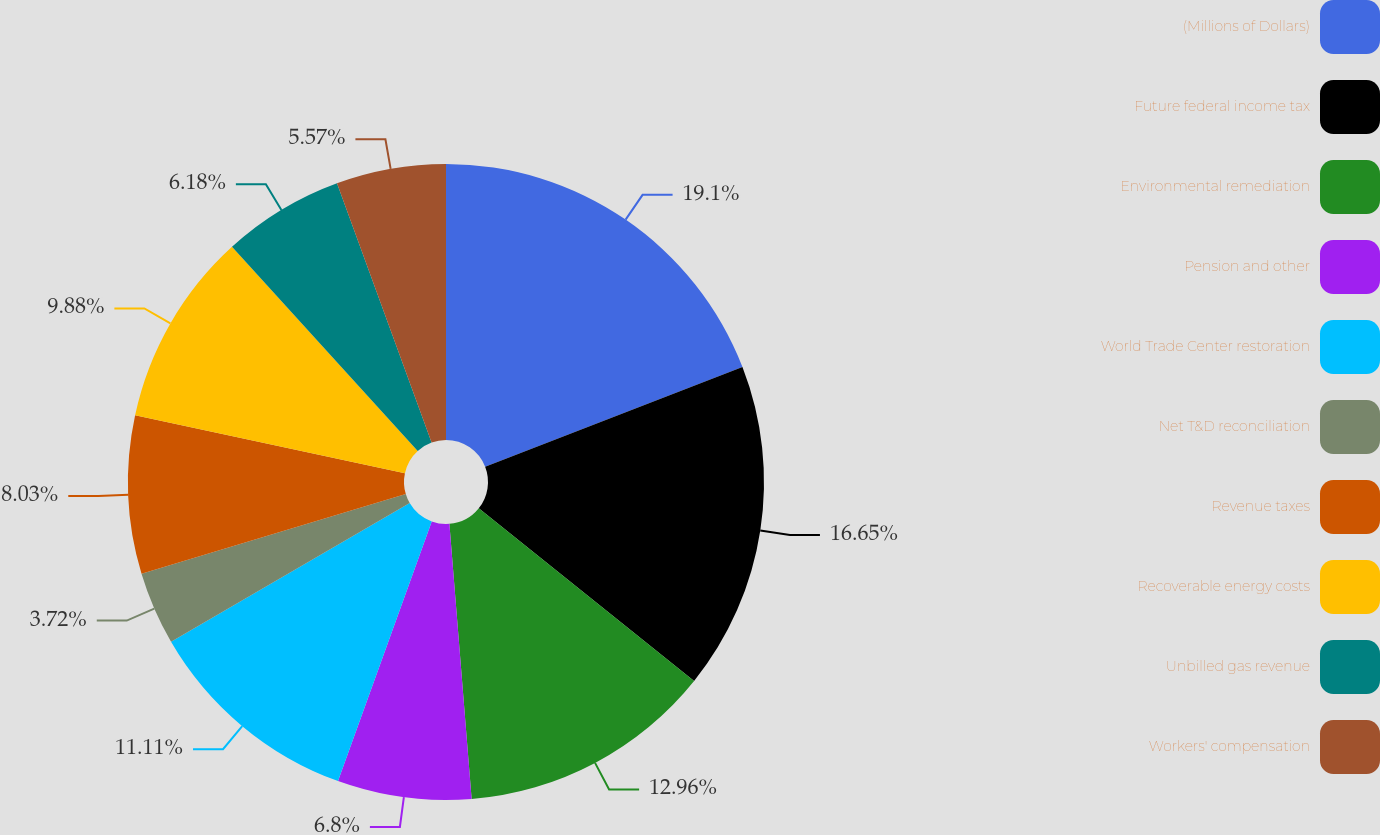Convert chart to OTSL. <chart><loc_0><loc_0><loc_500><loc_500><pie_chart><fcel>(Millions of Dollars)<fcel>Future federal income tax<fcel>Environmental remediation<fcel>Pension and other<fcel>World Trade Center restoration<fcel>Net T&D reconciliation<fcel>Revenue taxes<fcel>Recoverable energy costs<fcel>Unbilled gas revenue<fcel>Workers' compensation<nl><fcel>19.11%<fcel>16.65%<fcel>12.96%<fcel>6.8%<fcel>11.11%<fcel>3.72%<fcel>8.03%<fcel>9.88%<fcel>6.18%<fcel>5.57%<nl></chart> 